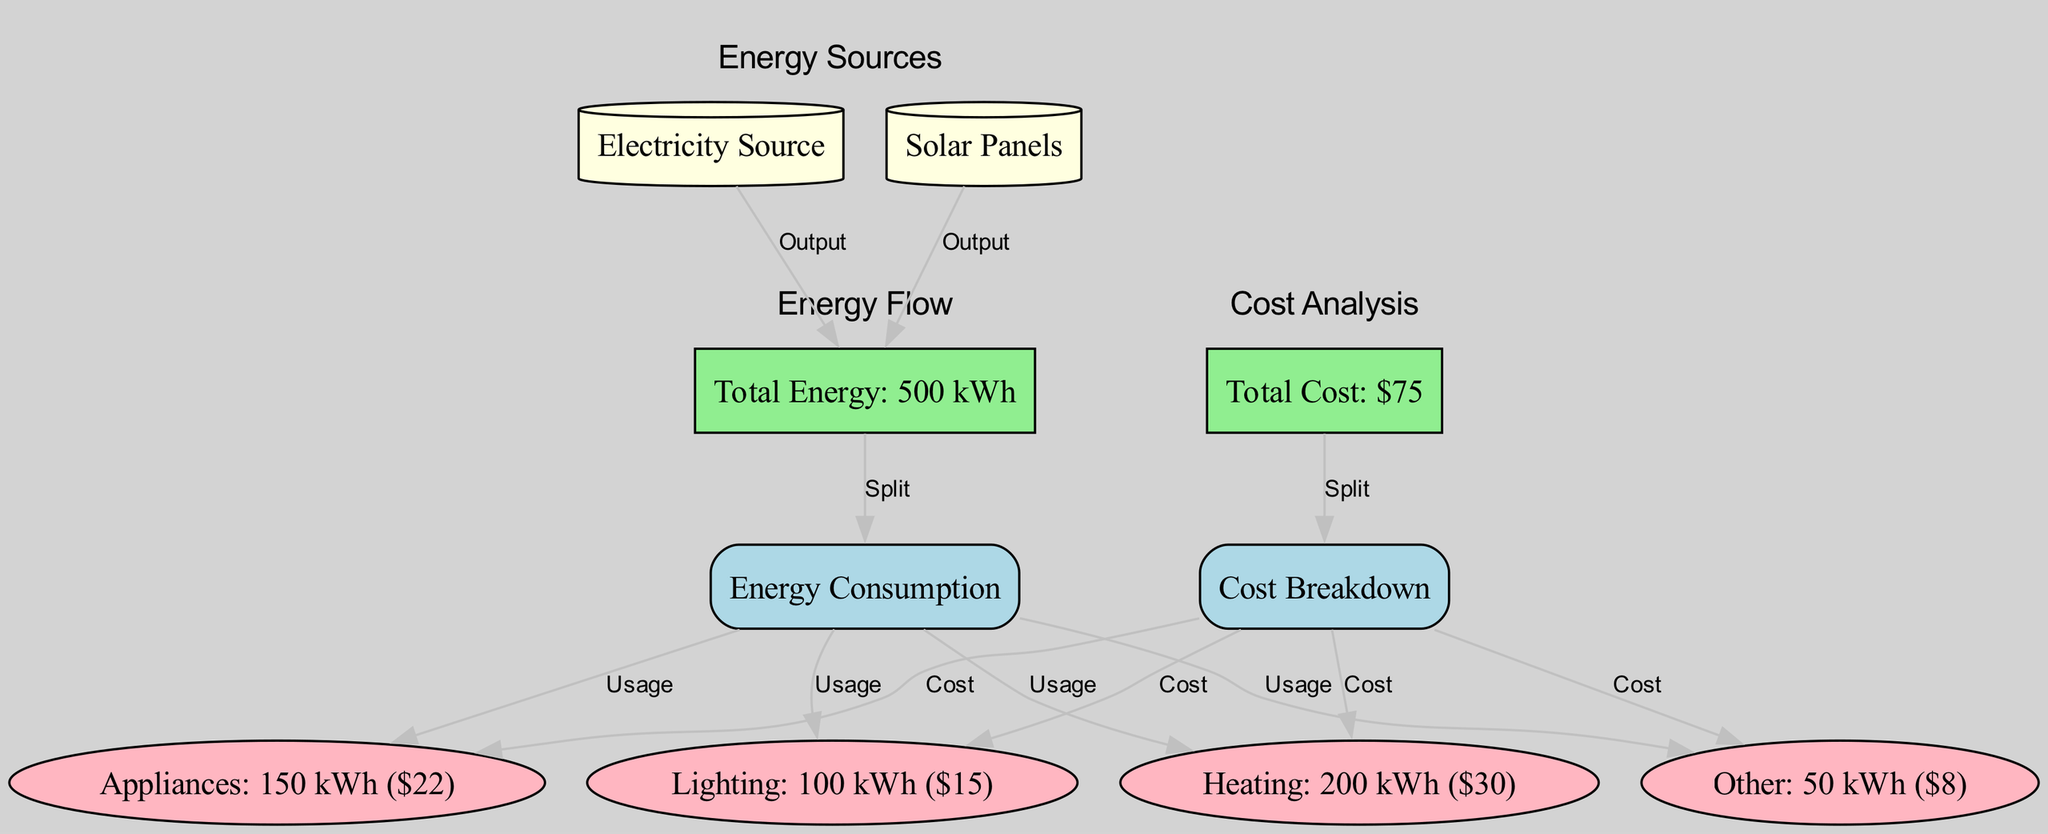What is the total energy consumption? The total energy consumption is centrally represented as "Total Energy: 500 kWh" in the diagram. This is the overall amount of energy used, combining all categories of usage.
Answer: 500 kWh What is the cost of lighting? The cost of lighting is indicated next to its usage, shown as "Lighting: 100 kWh ($15)". This highlights both the energy consumption and the associated cost for this specific category.
Answer: $15 How much energy is consumed by appliances? In the diagram, appliances consume "150 kWh", as indicated in the node labeled "Appliances: 150 kWh ($22)". This value is explicitly mentioned next to the appliances' usage data.
Answer: 150 kWh What is the total cost of the energy consumed? The total cost of the energy consumed is clearly represented as "Total Cost: $75", which sums up the costs associated with each category of consumption in the diagram.
Answer: $75 Which category consumes the most energy? The category "Heating" is listed as consuming "200 kWh", which is the highest value compared to other categories (Lighting, Appliances, Other), leading to this conclusion.
Answer: Heating What is the relationship between "Solar Panels" and "Total Energy"? The relationship is described as an "Output" from the "Solar Panels" node to the "Total Energy" node, indicating that solar panels contribute energy to the overall consumption.
Answer: Output What is the cost contribution of heating to the total cost? The cost contribution of heating is specified as "$30" in the node labeled "Heating: 200 kWh ($30)", showing its specific cost impact on the total expenses.
Answer: $30 How many nodes are categorized as usage? There are four nodes categorized as usage: Heating, Lighting, Appliances, and Other. Each one represents a distinct category of energy consumption in the diagram.
Answer: 4 What resource type is represented as a cylinder? The node "Electricity Source" is represented as a cylinder in the diagram, which designates it as a resource within the overall energy framework.
Answer: Electricity Source 